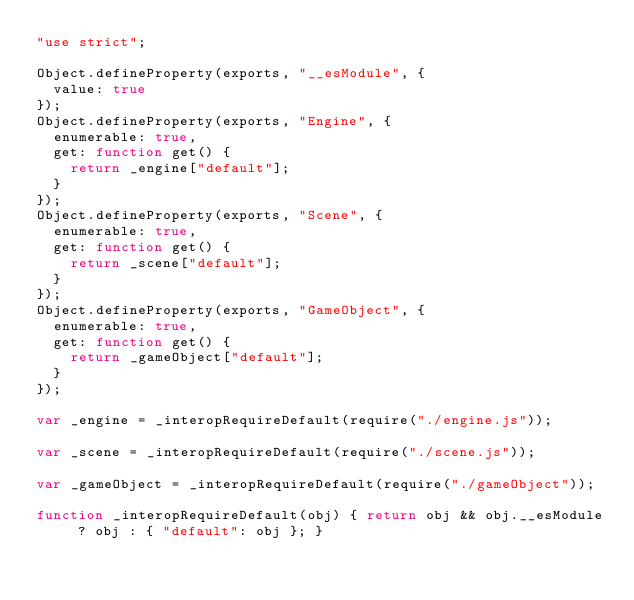<code> <loc_0><loc_0><loc_500><loc_500><_JavaScript_>"use strict";

Object.defineProperty(exports, "__esModule", {
  value: true
});
Object.defineProperty(exports, "Engine", {
  enumerable: true,
  get: function get() {
    return _engine["default"];
  }
});
Object.defineProperty(exports, "Scene", {
  enumerable: true,
  get: function get() {
    return _scene["default"];
  }
});
Object.defineProperty(exports, "GameObject", {
  enumerable: true,
  get: function get() {
    return _gameObject["default"];
  }
});

var _engine = _interopRequireDefault(require("./engine.js"));

var _scene = _interopRequireDefault(require("./scene.js"));

var _gameObject = _interopRequireDefault(require("./gameObject"));

function _interopRequireDefault(obj) { return obj && obj.__esModule ? obj : { "default": obj }; }</code> 